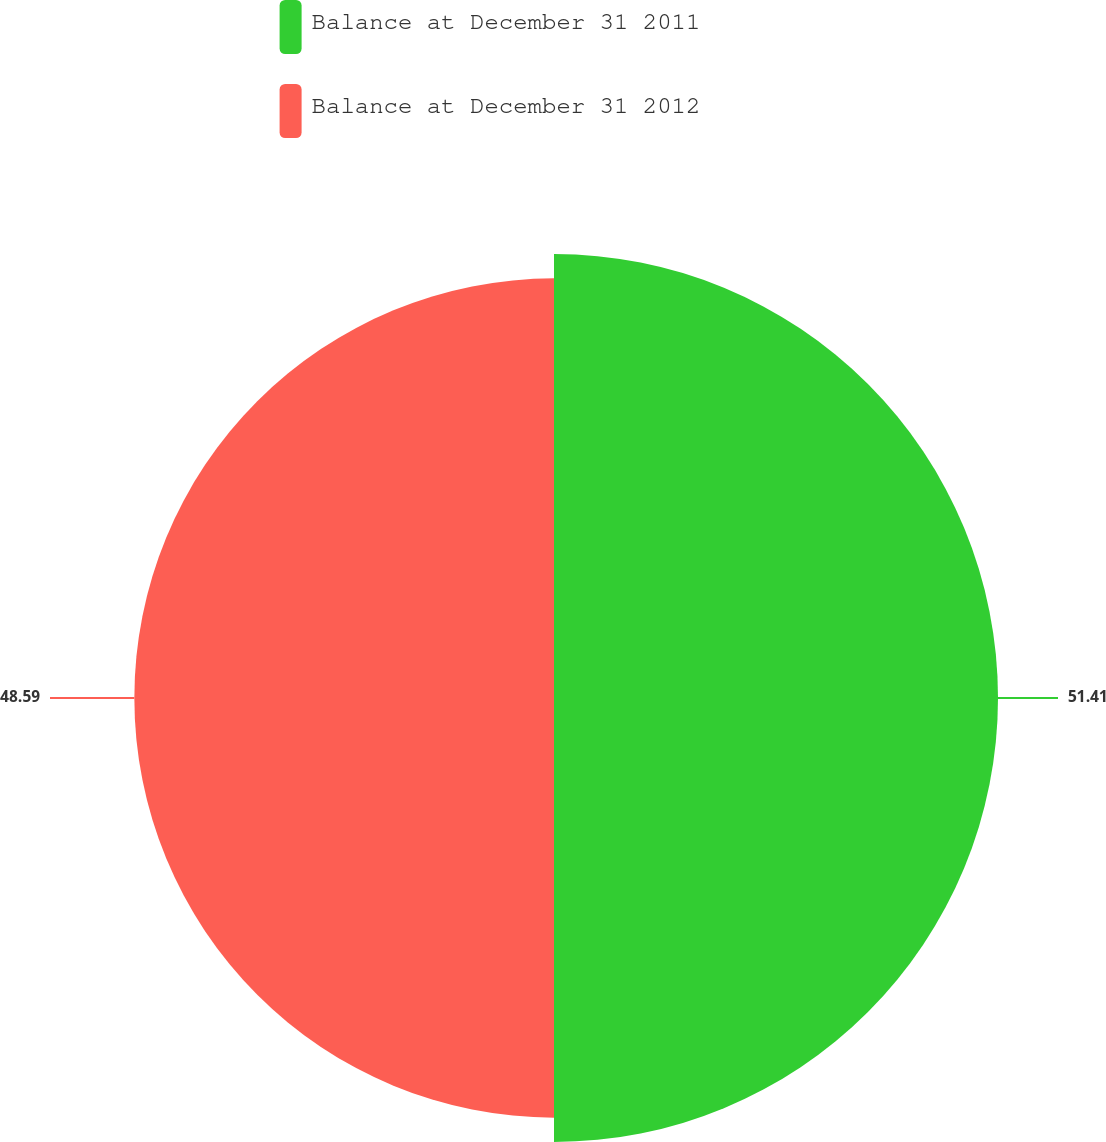Convert chart to OTSL. <chart><loc_0><loc_0><loc_500><loc_500><pie_chart><fcel>Balance at December 31 2011<fcel>Balance at December 31 2012<nl><fcel>51.41%<fcel>48.59%<nl></chart> 